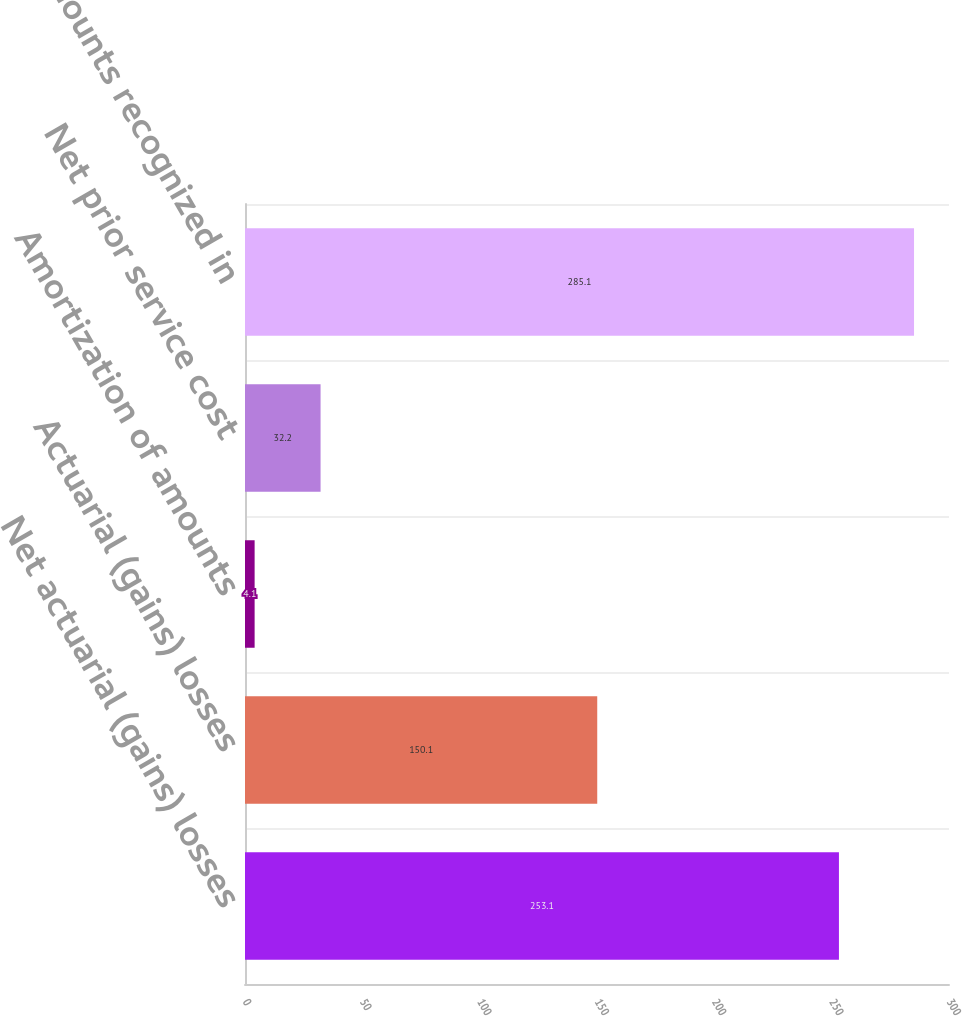<chart> <loc_0><loc_0><loc_500><loc_500><bar_chart><fcel>Net actuarial (gains) losses<fcel>Actuarial (gains) losses<fcel>Amortization of amounts<fcel>Net prior service cost<fcel>Total amounts recognized in<nl><fcel>253.1<fcel>150.1<fcel>4.1<fcel>32.2<fcel>285.1<nl></chart> 